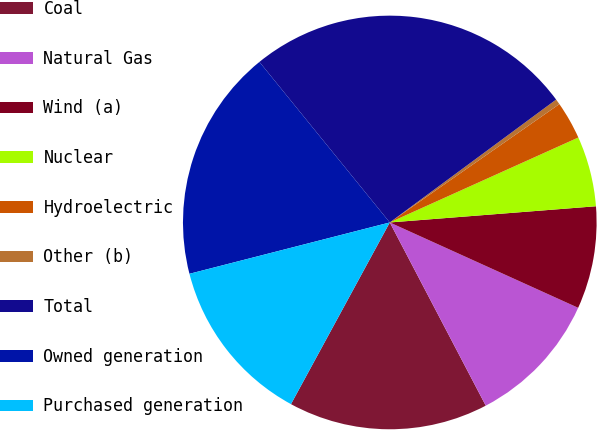<chart> <loc_0><loc_0><loc_500><loc_500><pie_chart><fcel>Coal<fcel>Natural Gas<fcel>Wind (a)<fcel>Nuclear<fcel>Hydroelectric<fcel>Other (b)<fcel>Total<fcel>Owned generation<fcel>Purchased generation<nl><fcel>15.61%<fcel>10.55%<fcel>8.02%<fcel>5.49%<fcel>2.96%<fcel>0.43%<fcel>25.73%<fcel>18.14%<fcel>13.08%<nl></chart> 